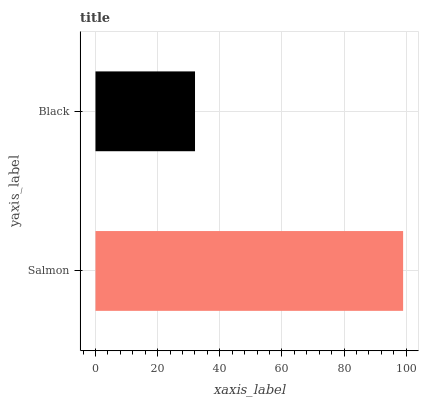Is Black the minimum?
Answer yes or no. Yes. Is Salmon the maximum?
Answer yes or no. Yes. Is Black the maximum?
Answer yes or no. No. Is Salmon greater than Black?
Answer yes or no. Yes. Is Black less than Salmon?
Answer yes or no. Yes. Is Black greater than Salmon?
Answer yes or no. No. Is Salmon less than Black?
Answer yes or no. No. Is Salmon the high median?
Answer yes or no. Yes. Is Black the low median?
Answer yes or no. Yes. Is Black the high median?
Answer yes or no. No. Is Salmon the low median?
Answer yes or no. No. 